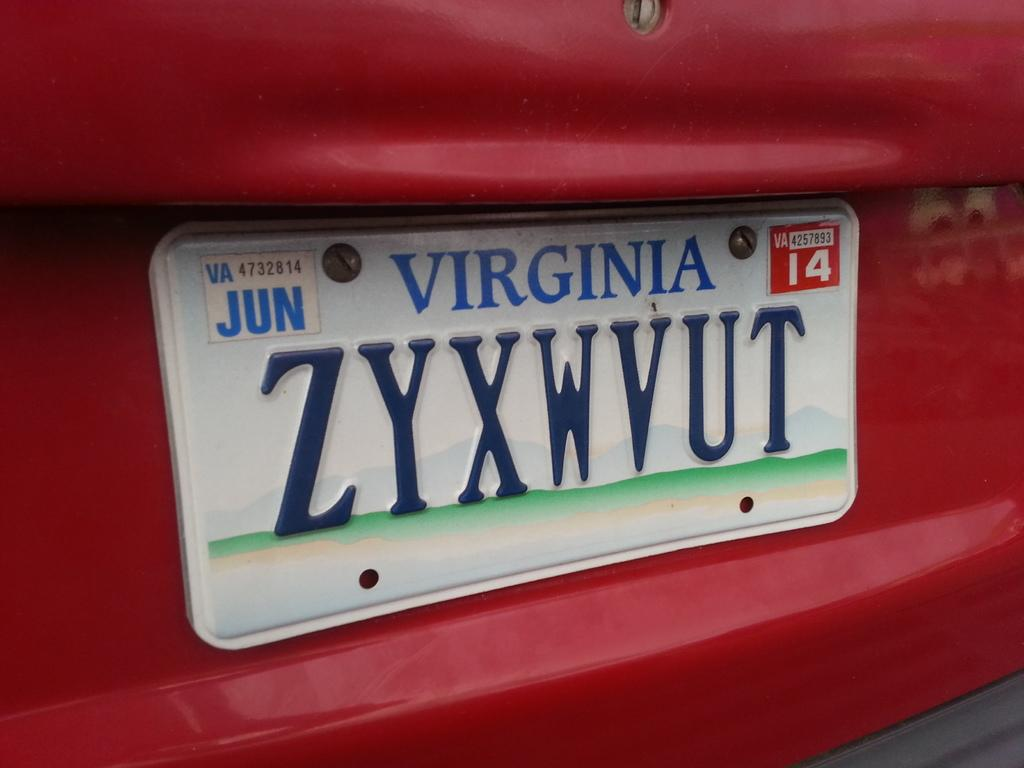<image>
Offer a succinct explanation of the picture presented. A Virginia license plate on a red vehicle. 